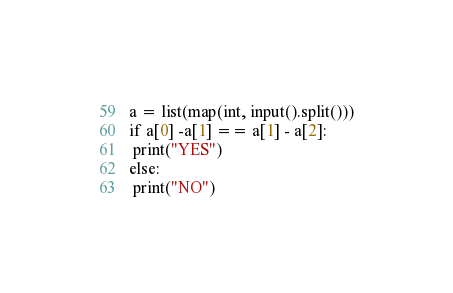Convert code to text. <code><loc_0><loc_0><loc_500><loc_500><_Python_>a = list(map(int, input().split()))
if a[0] -a[1] == a[1] - a[2]:
 print("YES")
else:
 print("NO")</code> 